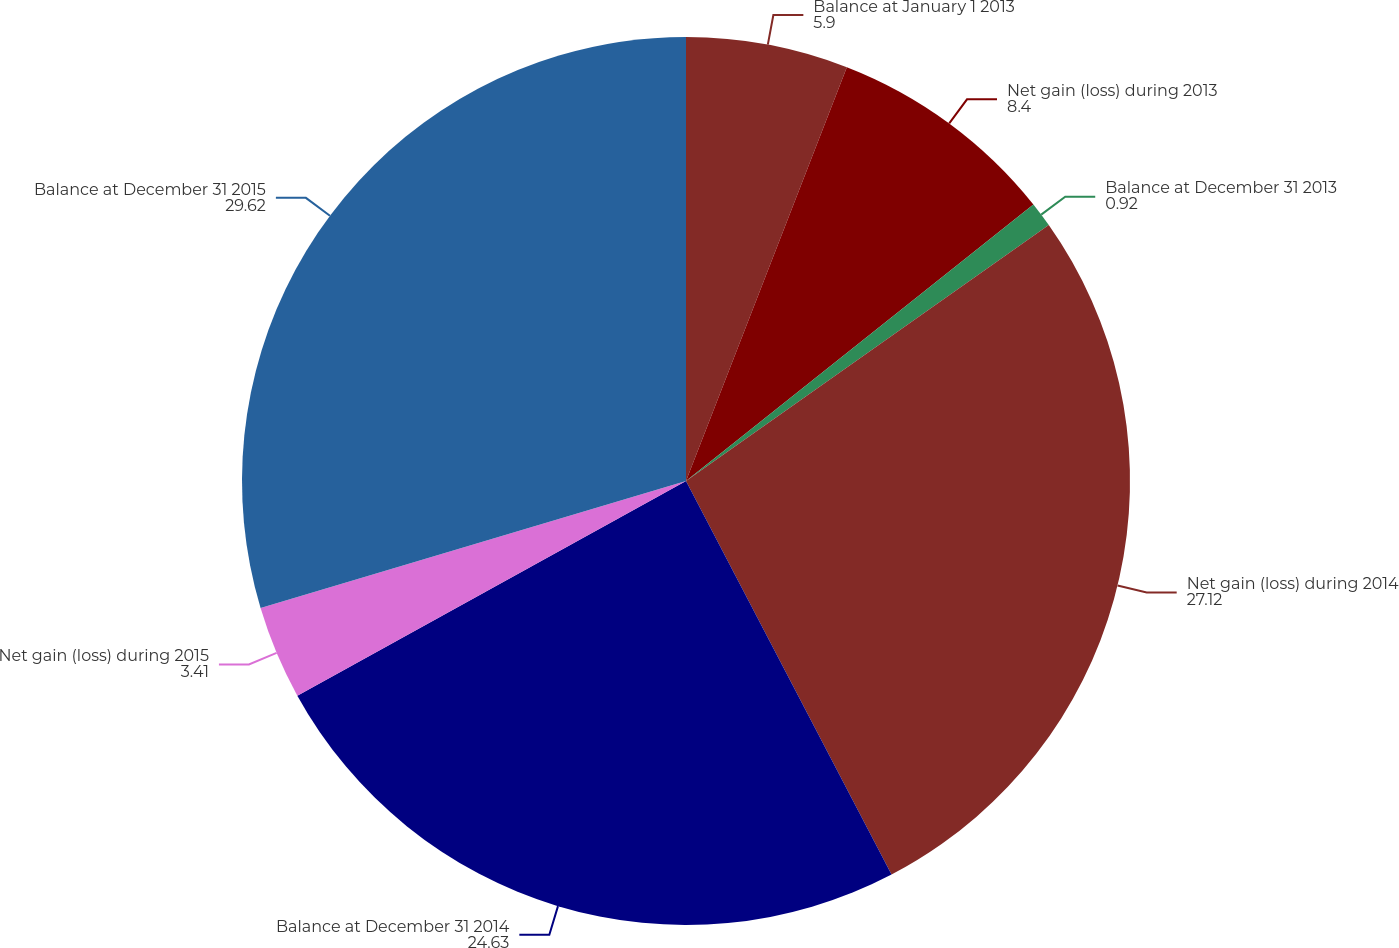Convert chart. <chart><loc_0><loc_0><loc_500><loc_500><pie_chart><fcel>Balance at January 1 2013<fcel>Net gain (loss) during 2013<fcel>Balance at December 31 2013<fcel>Net gain (loss) during 2014<fcel>Balance at December 31 2014<fcel>Net gain (loss) during 2015<fcel>Balance at December 31 2015<nl><fcel>5.9%<fcel>8.4%<fcel>0.92%<fcel>27.12%<fcel>24.63%<fcel>3.41%<fcel>29.62%<nl></chart> 